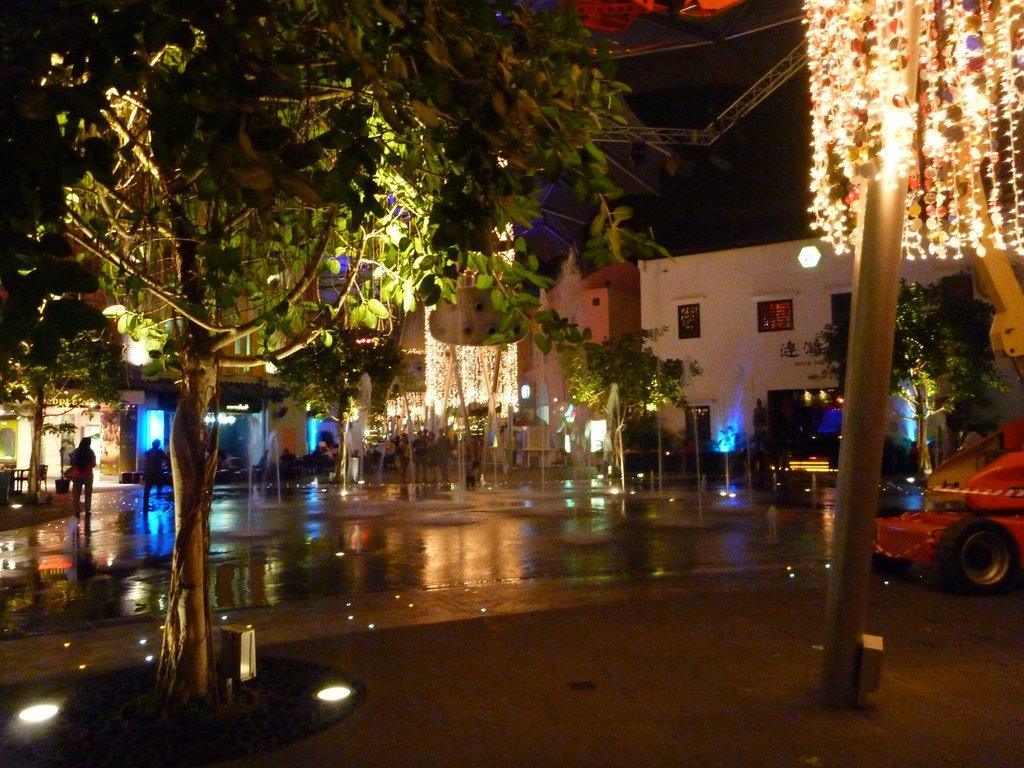What can be seen in the middle of the image? There are trees, vehicles, and people walking in the middle of the image. What type of structures are visible behind the trees? There are buildings behind the trees. What type of glass is being used to collect honey in the image? There is no glass or honey present in the image. What substance is being used to create the buildings in the image? The buildings in the image are made of materials such as concrete, bricks, or steel, not a substance mentioned in the absurd topics. 